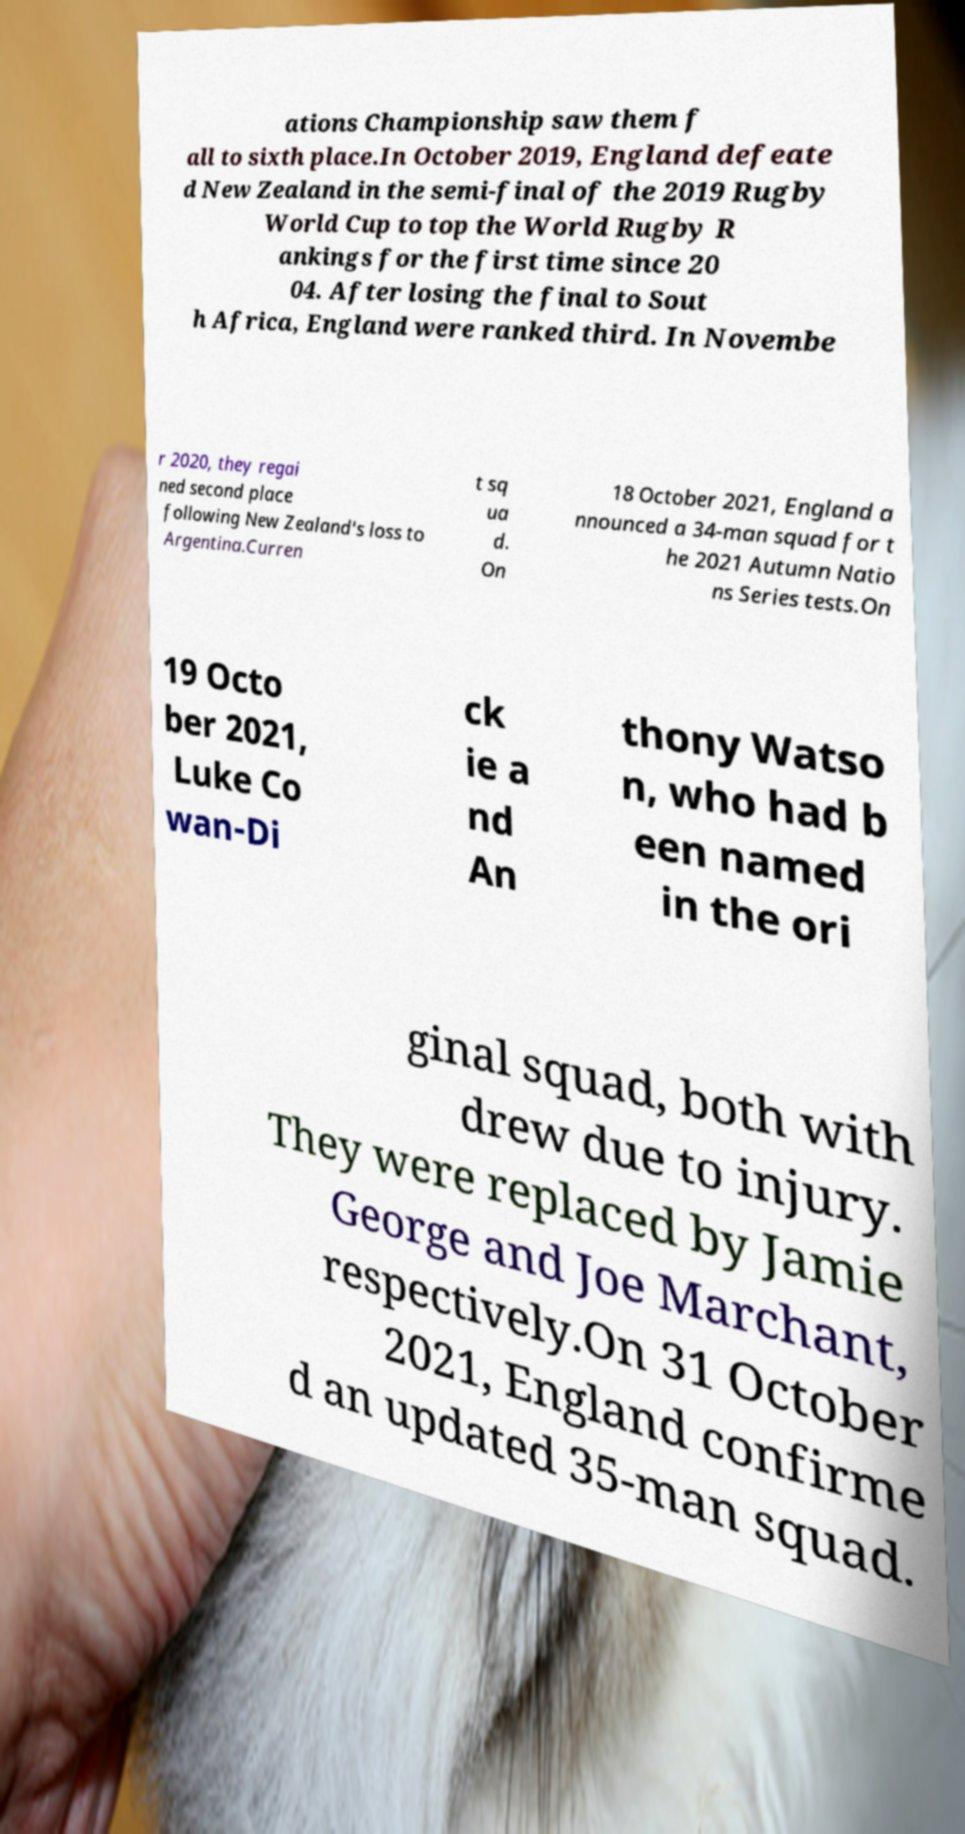For documentation purposes, I need the text within this image transcribed. Could you provide that? ations Championship saw them f all to sixth place.In October 2019, England defeate d New Zealand in the semi-final of the 2019 Rugby World Cup to top the World Rugby R ankings for the first time since 20 04. After losing the final to Sout h Africa, England were ranked third. In Novembe r 2020, they regai ned second place following New Zealand's loss to Argentina.Curren t sq ua d. On 18 October 2021, England a nnounced a 34-man squad for t he 2021 Autumn Natio ns Series tests.On 19 Octo ber 2021, Luke Co wan-Di ck ie a nd An thony Watso n, who had b een named in the ori ginal squad, both with drew due to injury. They were replaced by Jamie George and Joe Marchant, respectively.On 31 October 2021, England confirme d an updated 35-man squad. 